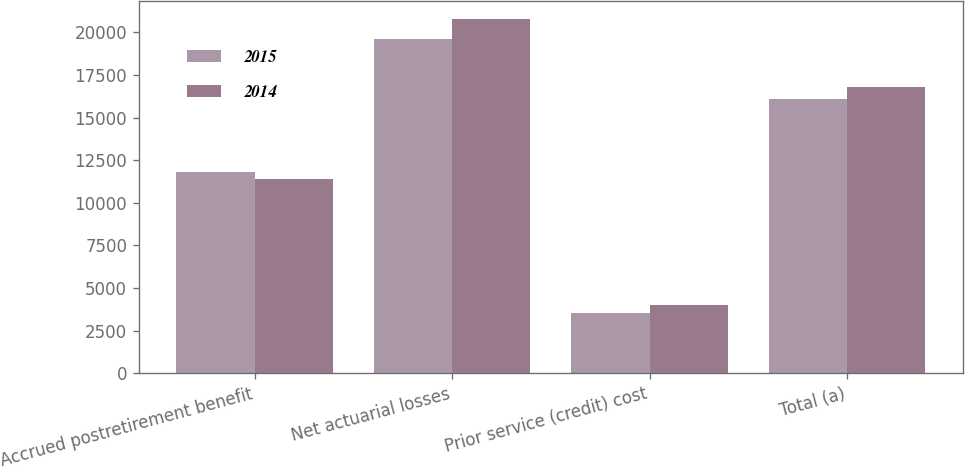<chart> <loc_0><loc_0><loc_500><loc_500><stacked_bar_chart><ecel><fcel>Accrued postretirement benefit<fcel>Net actuarial losses<fcel>Prior service (credit) cost<fcel>Total (a)<nl><fcel>2015<fcel>11807<fcel>19632<fcel>3565<fcel>16067<nl><fcel>2014<fcel>11413<fcel>20794<fcel>3985<fcel>16809<nl></chart> 